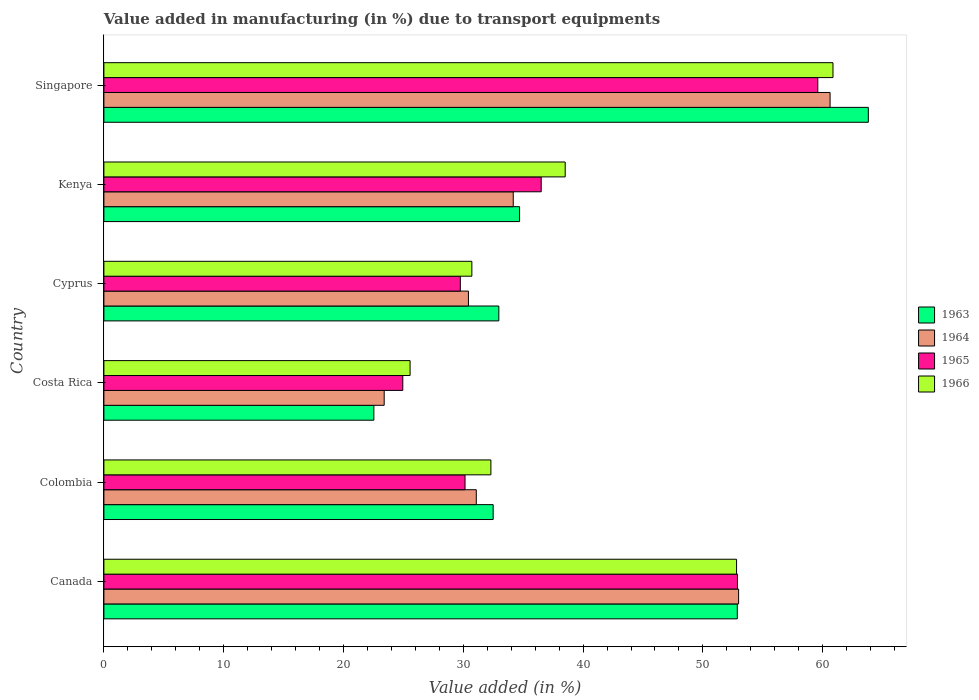How many groups of bars are there?
Your response must be concise. 6. Are the number of bars on each tick of the Y-axis equal?
Your response must be concise. Yes. How many bars are there on the 5th tick from the top?
Keep it short and to the point. 4. In how many cases, is the number of bars for a given country not equal to the number of legend labels?
Provide a succinct answer. 0. What is the percentage of value added in manufacturing due to transport equipments in 1966 in Kenya?
Your answer should be very brief. 38.51. Across all countries, what is the maximum percentage of value added in manufacturing due to transport equipments in 1963?
Provide a succinct answer. 63.81. Across all countries, what is the minimum percentage of value added in manufacturing due to transport equipments in 1965?
Provide a succinct answer. 24.95. In which country was the percentage of value added in manufacturing due to transport equipments in 1964 maximum?
Your answer should be compact. Singapore. What is the total percentage of value added in manufacturing due to transport equipments in 1964 in the graph?
Ensure brevity in your answer.  232.68. What is the difference between the percentage of value added in manufacturing due to transport equipments in 1966 in Costa Rica and that in Kenya?
Make the answer very short. -12.95. What is the difference between the percentage of value added in manufacturing due to transport equipments in 1965 in Cyprus and the percentage of value added in manufacturing due to transport equipments in 1966 in Kenya?
Make the answer very short. -8.75. What is the average percentage of value added in manufacturing due to transport equipments in 1966 per country?
Ensure brevity in your answer.  40.13. What is the difference between the percentage of value added in manufacturing due to transport equipments in 1964 and percentage of value added in manufacturing due to transport equipments in 1966 in Costa Rica?
Provide a succinct answer. -2.16. What is the ratio of the percentage of value added in manufacturing due to transport equipments in 1966 in Costa Rica to that in Kenya?
Ensure brevity in your answer.  0.66. What is the difference between the highest and the second highest percentage of value added in manufacturing due to transport equipments in 1966?
Provide a short and direct response. 8.05. What is the difference between the highest and the lowest percentage of value added in manufacturing due to transport equipments in 1964?
Offer a terse response. 37.22. Is the sum of the percentage of value added in manufacturing due to transport equipments in 1963 in Colombia and Singapore greater than the maximum percentage of value added in manufacturing due to transport equipments in 1965 across all countries?
Offer a terse response. Yes. Is it the case that in every country, the sum of the percentage of value added in manufacturing due to transport equipments in 1964 and percentage of value added in manufacturing due to transport equipments in 1965 is greater than the sum of percentage of value added in manufacturing due to transport equipments in 1966 and percentage of value added in manufacturing due to transport equipments in 1963?
Your answer should be very brief. No. What does the 2nd bar from the top in Kenya represents?
Offer a terse response. 1965. What does the 3rd bar from the bottom in Singapore represents?
Ensure brevity in your answer.  1965. How many countries are there in the graph?
Your answer should be very brief. 6. What is the difference between two consecutive major ticks on the X-axis?
Your answer should be very brief. 10. Are the values on the major ticks of X-axis written in scientific E-notation?
Offer a very short reply. No. Where does the legend appear in the graph?
Provide a succinct answer. Center right. How are the legend labels stacked?
Offer a terse response. Vertical. What is the title of the graph?
Make the answer very short. Value added in manufacturing (in %) due to transport equipments. What is the label or title of the X-axis?
Keep it short and to the point. Value added (in %). What is the Value added (in %) in 1963 in Canada?
Your answer should be compact. 52.87. What is the Value added (in %) of 1964 in Canada?
Give a very brief answer. 52.98. What is the Value added (in %) in 1965 in Canada?
Give a very brief answer. 52.89. What is the Value added (in %) in 1966 in Canada?
Keep it short and to the point. 52.81. What is the Value added (in %) of 1963 in Colombia?
Offer a very short reply. 32.49. What is the Value added (in %) of 1964 in Colombia?
Ensure brevity in your answer.  31.09. What is the Value added (in %) in 1965 in Colombia?
Provide a succinct answer. 30.15. What is the Value added (in %) in 1966 in Colombia?
Your answer should be compact. 32.3. What is the Value added (in %) of 1963 in Costa Rica?
Your response must be concise. 22.53. What is the Value added (in %) in 1964 in Costa Rica?
Provide a short and direct response. 23.4. What is the Value added (in %) of 1965 in Costa Rica?
Your response must be concise. 24.95. What is the Value added (in %) of 1966 in Costa Rica?
Provide a succinct answer. 25.56. What is the Value added (in %) in 1963 in Cyprus?
Your answer should be compact. 32.97. What is the Value added (in %) of 1964 in Cyprus?
Make the answer very short. 30.43. What is the Value added (in %) in 1965 in Cyprus?
Offer a terse response. 29.75. What is the Value added (in %) in 1966 in Cyprus?
Your response must be concise. 30.72. What is the Value added (in %) of 1963 in Kenya?
Keep it short and to the point. 34.7. What is the Value added (in %) of 1964 in Kenya?
Provide a short and direct response. 34.17. What is the Value added (in %) of 1965 in Kenya?
Provide a succinct answer. 36.5. What is the Value added (in %) in 1966 in Kenya?
Make the answer very short. 38.51. What is the Value added (in %) in 1963 in Singapore?
Provide a short and direct response. 63.81. What is the Value added (in %) of 1964 in Singapore?
Offer a terse response. 60.62. What is the Value added (in %) in 1965 in Singapore?
Your answer should be very brief. 59.59. What is the Value added (in %) of 1966 in Singapore?
Offer a terse response. 60.86. Across all countries, what is the maximum Value added (in %) in 1963?
Make the answer very short. 63.81. Across all countries, what is the maximum Value added (in %) of 1964?
Your answer should be very brief. 60.62. Across all countries, what is the maximum Value added (in %) in 1965?
Your response must be concise. 59.59. Across all countries, what is the maximum Value added (in %) in 1966?
Offer a terse response. 60.86. Across all countries, what is the minimum Value added (in %) of 1963?
Your answer should be very brief. 22.53. Across all countries, what is the minimum Value added (in %) in 1964?
Provide a succinct answer. 23.4. Across all countries, what is the minimum Value added (in %) of 1965?
Your response must be concise. 24.95. Across all countries, what is the minimum Value added (in %) of 1966?
Provide a succinct answer. 25.56. What is the total Value added (in %) of 1963 in the graph?
Ensure brevity in your answer.  239.38. What is the total Value added (in %) in 1964 in the graph?
Provide a succinct answer. 232.68. What is the total Value added (in %) in 1965 in the graph?
Make the answer very short. 233.83. What is the total Value added (in %) of 1966 in the graph?
Make the answer very short. 240.76. What is the difference between the Value added (in %) in 1963 in Canada and that in Colombia?
Offer a very short reply. 20.38. What is the difference between the Value added (in %) of 1964 in Canada and that in Colombia?
Give a very brief answer. 21.9. What is the difference between the Value added (in %) in 1965 in Canada and that in Colombia?
Your answer should be compact. 22.74. What is the difference between the Value added (in %) in 1966 in Canada and that in Colombia?
Your answer should be very brief. 20.51. What is the difference between the Value added (in %) in 1963 in Canada and that in Costa Rica?
Give a very brief answer. 30.34. What is the difference between the Value added (in %) in 1964 in Canada and that in Costa Rica?
Provide a succinct answer. 29.59. What is the difference between the Value added (in %) in 1965 in Canada and that in Costa Rica?
Keep it short and to the point. 27.93. What is the difference between the Value added (in %) in 1966 in Canada and that in Costa Rica?
Provide a succinct answer. 27.25. What is the difference between the Value added (in %) of 1963 in Canada and that in Cyprus?
Offer a very short reply. 19.91. What is the difference between the Value added (in %) in 1964 in Canada and that in Cyprus?
Ensure brevity in your answer.  22.55. What is the difference between the Value added (in %) in 1965 in Canada and that in Cyprus?
Make the answer very short. 23.13. What is the difference between the Value added (in %) of 1966 in Canada and that in Cyprus?
Make the answer very short. 22.1. What is the difference between the Value added (in %) in 1963 in Canada and that in Kenya?
Offer a terse response. 18.17. What is the difference between the Value added (in %) in 1964 in Canada and that in Kenya?
Offer a very short reply. 18.81. What is the difference between the Value added (in %) in 1965 in Canada and that in Kenya?
Your response must be concise. 16.38. What is the difference between the Value added (in %) in 1966 in Canada and that in Kenya?
Your answer should be compact. 14.3. What is the difference between the Value added (in %) of 1963 in Canada and that in Singapore?
Offer a very short reply. -10.94. What is the difference between the Value added (in %) of 1964 in Canada and that in Singapore?
Keep it short and to the point. -7.63. What is the difference between the Value added (in %) in 1965 in Canada and that in Singapore?
Your answer should be very brief. -6.71. What is the difference between the Value added (in %) of 1966 in Canada and that in Singapore?
Give a very brief answer. -8.05. What is the difference between the Value added (in %) in 1963 in Colombia and that in Costa Rica?
Provide a succinct answer. 9.96. What is the difference between the Value added (in %) of 1964 in Colombia and that in Costa Rica?
Offer a very short reply. 7.69. What is the difference between the Value added (in %) in 1965 in Colombia and that in Costa Rica?
Give a very brief answer. 5.2. What is the difference between the Value added (in %) of 1966 in Colombia and that in Costa Rica?
Offer a terse response. 6.74. What is the difference between the Value added (in %) of 1963 in Colombia and that in Cyprus?
Keep it short and to the point. -0.47. What is the difference between the Value added (in %) of 1964 in Colombia and that in Cyprus?
Provide a succinct answer. 0.66. What is the difference between the Value added (in %) of 1965 in Colombia and that in Cyprus?
Your answer should be very brief. 0.39. What is the difference between the Value added (in %) in 1966 in Colombia and that in Cyprus?
Make the answer very short. 1.59. What is the difference between the Value added (in %) of 1963 in Colombia and that in Kenya?
Your answer should be very brief. -2.21. What is the difference between the Value added (in %) in 1964 in Colombia and that in Kenya?
Your answer should be very brief. -3.08. What is the difference between the Value added (in %) of 1965 in Colombia and that in Kenya?
Your answer should be very brief. -6.36. What is the difference between the Value added (in %) of 1966 in Colombia and that in Kenya?
Make the answer very short. -6.2. What is the difference between the Value added (in %) of 1963 in Colombia and that in Singapore?
Provide a short and direct response. -31.32. What is the difference between the Value added (in %) in 1964 in Colombia and that in Singapore?
Provide a succinct answer. -29.53. What is the difference between the Value added (in %) in 1965 in Colombia and that in Singapore?
Provide a short and direct response. -29.45. What is the difference between the Value added (in %) of 1966 in Colombia and that in Singapore?
Your answer should be very brief. -28.56. What is the difference between the Value added (in %) in 1963 in Costa Rica and that in Cyprus?
Ensure brevity in your answer.  -10.43. What is the difference between the Value added (in %) in 1964 in Costa Rica and that in Cyprus?
Provide a succinct answer. -7.03. What is the difference between the Value added (in %) of 1965 in Costa Rica and that in Cyprus?
Your answer should be very brief. -4.8. What is the difference between the Value added (in %) of 1966 in Costa Rica and that in Cyprus?
Make the answer very short. -5.16. What is the difference between the Value added (in %) in 1963 in Costa Rica and that in Kenya?
Ensure brevity in your answer.  -12.17. What is the difference between the Value added (in %) in 1964 in Costa Rica and that in Kenya?
Provide a succinct answer. -10.77. What is the difference between the Value added (in %) in 1965 in Costa Rica and that in Kenya?
Your answer should be compact. -11.55. What is the difference between the Value added (in %) of 1966 in Costa Rica and that in Kenya?
Your answer should be compact. -12.95. What is the difference between the Value added (in %) of 1963 in Costa Rica and that in Singapore?
Provide a short and direct response. -41.28. What is the difference between the Value added (in %) in 1964 in Costa Rica and that in Singapore?
Ensure brevity in your answer.  -37.22. What is the difference between the Value added (in %) of 1965 in Costa Rica and that in Singapore?
Your response must be concise. -34.64. What is the difference between the Value added (in %) in 1966 in Costa Rica and that in Singapore?
Your answer should be compact. -35.3. What is the difference between the Value added (in %) in 1963 in Cyprus and that in Kenya?
Give a very brief answer. -1.73. What is the difference between the Value added (in %) in 1964 in Cyprus and that in Kenya?
Your response must be concise. -3.74. What is the difference between the Value added (in %) in 1965 in Cyprus and that in Kenya?
Your answer should be compact. -6.75. What is the difference between the Value added (in %) in 1966 in Cyprus and that in Kenya?
Provide a short and direct response. -7.79. What is the difference between the Value added (in %) in 1963 in Cyprus and that in Singapore?
Provide a succinct answer. -30.84. What is the difference between the Value added (in %) of 1964 in Cyprus and that in Singapore?
Ensure brevity in your answer.  -30.19. What is the difference between the Value added (in %) of 1965 in Cyprus and that in Singapore?
Ensure brevity in your answer.  -29.84. What is the difference between the Value added (in %) of 1966 in Cyprus and that in Singapore?
Your response must be concise. -30.14. What is the difference between the Value added (in %) in 1963 in Kenya and that in Singapore?
Your response must be concise. -29.11. What is the difference between the Value added (in %) in 1964 in Kenya and that in Singapore?
Offer a terse response. -26.45. What is the difference between the Value added (in %) of 1965 in Kenya and that in Singapore?
Give a very brief answer. -23.09. What is the difference between the Value added (in %) in 1966 in Kenya and that in Singapore?
Your response must be concise. -22.35. What is the difference between the Value added (in %) in 1963 in Canada and the Value added (in %) in 1964 in Colombia?
Your answer should be compact. 21.79. What is the difference between the Value added (in %) in 1963 in Canada and the Value added (in %) in 1965 in Colombia?
Provide a short and direct response. 22.73. What is the difference between the Value added (in %) in 1963 in Canada and the Value added (in %) in 1966 in Colombia?
Provide a succinct answer. 20.57. What is the difference between the Value added (in %) of 1964 in Canada and the Value added (in %) of 1965 in Colombia?
Ensure brevity in your answer.  22.84. What is the difference between the Value added (in %) in 1964 in Canada and the Value added (in %) in 1966 in Colombia?
Offer a terse response. 20.68. What is the difference between the Value added (in %) of 1965 in Canada and the Value added (in %) of 1966 in Colombia?
Your response must be concise. 20.58. What is the difference between the Value added (in %) of 1963 in Canada and the Value added (in %) of 1964 in Costa Rica?
Offer a very short reply. 29.48. What is the difference between the Value added (in %) of 1963 in Canada and the Value added (in %) of 1965 in Costa Rica?
Provide a short and direct response. 27.92. What is the difference between the Value added (in %) in 1963 in Canada and the Value added (in %) in 1966 in Costa Rica?
Give a very brief answer. 27.31. What is the difference between the Value added (in %) of 1964 in Canada and the Value added (in %) of 1965 in Costa Rica?
Provide a succinct answer. 28.03. What is the difference between the Value added (in %) of 1964 in Canada and the Value added (in %) of 1966 in Costa Rica?
Your answer should be very brief. 27.42. What is the difference between the Value added (in %) of 1965 in Canada and the Value added (in %) of 1966 in Costa Rica?
Your answer should be very brief. 27.33. What is the difference between the Value added (in %) of 1963 in Canada and the Value added (in %) of 1964 in Cyprus?
Offer a terse response. 22.44. What is the difference between the Value added (in %) in 1963 in Canada and the Value added (in %) in 1965 in Cyprus?
Ensure brevity in your answer.  23.12. What is the difference between the Value added (in %) of 1963 in Canada and the Value added (in %) of 1966 in Cyprus?
Your answer should be compact. 22.16. What is the difference between the Value added (in %) in 1964 in Canada and the Value added (in %) in 1965 in Cyprus?
Your answer should be very brief. 23.23. What is the difference between the Value added (in %) in 1964 in Canada and the Value added (in %) in 1966 in Cyprus?
Provide a succinct answer. 22.27. What is the difference between the Value added (in %) in 1965 in Canada and the Value added (in %) in 1966 in Cyprus?
Make the answer very short. 22.17. What is the difference between the Value added (in %) of 1963 in Canada and the Value added (in %) of 1964 in Kenya?
Your answer should be compact. 18.7. What is the difference between the Value added (in %) in 1963 in Canada and the Value added (in %) in 1965 in Kenya?
Your answer should be compact. 16.37. What is the difference between the Value added (in %) of 1963 in Canada and the Value added (in %) of 1966 in Kenya?
Offer a terse response. 14.37. What is the difference between the Value added (in %) in 1964 in Canada and the Value added (in %) in 1965 in Kenya?
Provide a succinct answer. 16.48. What is the difference between the Value added (in %) in 1964 in Canada and the Value added (in %) in 1966 in Kenya?
Offer a very short reply. 14.47. What is the difference between the Value added (in %) in 1965 in Canada and the Value added (in %) in 1966 in Kenya?
Provide a succinct answer. 14.38. What is the difference between the Value added (in %) in 1963 in Canada and the Value added (in %) in 1964 in Singapore?
Your answer should be compact. -7.74. What is the difference between the Value added (in %) in 1963 in Canada and the Value added (in %) in 1965 in Singapore?
Offer a very short reply. -6.72. What is the difference between the Value added (in %) in 1963 in Canada and the Value added (in %) in 1966 in Singapore?
Your answer should be very brief. -7.99. What is the difference between the Value added (in %) of 1964 in Canada and the Value added (in %) of 1965 in Singapore?
Keep it short and to the point. -6.61. What is the difference between the Value added (in %) in 1964 in Canada and the Value added (in %) in 1966 in Singapore?
Give a very brief answer. -7.88. What is the difference between the Value added (in %) of 1965 in Canada and the Value added (in %) of 1966 in Singapore?
Offer a very short reply. -7.97. What is the difference between the Value added (in %) of 1963 in Colombia and the Value added (in %) of 1964 in Costa Rica?
Make the answer very short. 9.1. What is the difference between the Value added (in %) in 1963 in Colombia and the Value added (in %) in 1965 in Costa Rica?
Provide a short and direct response. 7.54. What is the difference between the Value added (in %) of 1963 in Colombia and the Value added (in %) of 1966 in Costa Rica?
Your answer should be very brief. 6.93. What is the difference between the Value added (in %) in 1964 in Colombia and the Value added (in %) in 1965 in Costa Rica?
Your answer should be compact. 6.14. What is the difference between the Value added (in %) in 1964 in Colombia and the Value added (in %) in 1966 in Costa Rica?
Offer a very short reply. 5.53. What is the difference between the Value added (in %) of 1965 in Colombia and the Value added (in %) of 1966 in Costa Rica?
Your response must be concise. 4.59. What is the difference between the Value added (in %) in 1963 in Colombia and the Value added (in %) in 1964 in Cyprus?
Ensure brevity in your answer.  2.06. What is the difference between the Value added (in %) in 1963 in Colombia and the Value added (in %) in 1965 in Cyprus?
Keep it short and to the point. 2.74. What is the difference between the Value added (in %) in 1963 in Colombia and the Value added (in %) in 1966 in Cyprus?
Make the answer very short. 1.78. What is the difference between the Value added (in %) in 1964 in Colombia and the Value added (in %) in 1965 in Cyprus?
Your answer should be very brief. 1.33. What is the difference between the Value added (in %) of 1964 in Colombia and the Value added (in %) of 1966 in Cyprus?
Your response must be concise. 0.37. What is the difference between the Value added (in %) of 1965 in Colombia and the Value added (in %) of 1966 in Cyprus?
Provide a short and direct response. -0.57. What is the difference between the Value added (in %) in 1963 in Colombia and the Value added (in %) in 1964 in Kenya?
Your answer should be very brief. -1.68. What is the difference between the Value added (in %) of 1963 in Colombia and the Value added (in %) of 1965 in Kenya?
Give a very brief answer. -4.01. What is the difference between the Value added (in %) in 1963 in Colombia and the Value added (in %) in 1966 in Kenya?
Your answer should be very brief. -6.01. What is the difference between the Value added (in %) of 1964 in Colombia and the Value added (in %) of 1965 in Kenya?
Give a very brief answer. -5.42. What is the difference between the Value added (in %) in 1964 in Colombia and the Value added (in %) in 1966 in Kenya?
Provide a short and direct response. -7.42. What is the difference between the Value added (in %) of 1965 in Colombia and the Value added (in %) of 1966 in Kenya?
Your answer should be very brief. -8.36. What is the difference between the Value added (in %) of 1963 in Colombia and the Value added (in %) of 1964 in Singapore?
Provide a short and direct response. -28.12. What is the difference between the Value added (in %) in 1963 in Colombia and the Value added (in %) in 1965 in Singapore?
Keep it short and to the point. -27.1. What is the difference between the Value added (in %) in 1963 in Colombia and the Value added (in %) in 1966 in Singapore?
Ensure brevity in your answer.  -28.37. What is the difference between the Value added (in %) in 1964 in Colombia and the Value added (in %) in 1965 in Singapore?
Make the answer very short. -28.51. What is the difference between the Value added (in %) in 1964 in Colombia and the Value added (in %) in 1966 in Singapore?
Provide a succinct answer. -29.77. What is the difference between the Value added (in %) in 1965 in Colombia and the Value added (in %) in 1966 in Singapore?
Your response must be concise. -30.71. What is the difference between the Value added (in %) of 1963 in Costa Rica and the Value added (in %) of 1964 in Cyprus?
Provide a succinct answer. -7.9. What is the difference between the Value added (in %) of 1963 in Costa Rica and the Value added (in %) of 1965 in Cyprus?
Your answer should be very brief. -7.22. What is the difference between the Value added (in %) of 1963 in Costa Rica and the Value added (in %) of 1966 in Cyprus?
Provide a succinct answer. -8.18. What is the difference between the Value added (in %) in 1964 in Costa Rica and the Value added (in %) in 1965 in Cyprus?
Keep it short and to the point. -6.36. What is the difference between the Value added (in %) in 1964 in Costa Rica and the Value added (in %) in 1966 in Cyprus?
Your response must be concise. -7.32. What is the difference between the Value added (in %) in 1965 in Costa Rica and the Value added (in %) in 1966 in Cyprus?
Make the answer very short. -5.77. What is the difference between the Value added (in %) of 1963 in Costa Rica and the Value added (in %) of 1964 in Kenya?
Keep it short and to the point. -11.64. What is the difference between the Value added (in %) in 1963 in Costa Rica and the Value added (in %) in 1965 in Kenya?
Give a very brief answer. -13.97. What is the difference between the Value added (in %) of 1963 in Costa Rica and the Value added (in %) of 1966 in Kenya?
Provide a short and direct response. -15.97. What is the difference between the Value added (in %) in 1964 in Costa Rica and the Value added (in %) in 1965 in Kenya?
Your response must be concise. -13.11. What is the difference between the Value added (in %) of 1964 in Costa Rica and the Value added (in %) of 1966 in Kenya?
Make the answer very short. -15.11. What is the difference between the Value added (in %) of 1965 in Costa Rica and the Value added (in %) of 1966 in Kenya?
Provide a succinct answer. -13.56. What is the difference between the Value added (in %) in 1963 in Costa Rica and the Value added (in %) in 1964 in Singapore?
Provide a succinct answer. -38.08. What is the difference between the Value added (in %) of 1963 in Costa Rica and the Value added (in %) of 1965 in Singapore?
Your answer should be very brief. -37.06. What is the difference between the Value added (in %) in 1963 in Costa Rica and the Value added (in %) in 1966 in Singapore?
Provide a succinct answer. -38.33. What is the difference between the Value added (in %) of 1964 in Costa Rica and the Value added (in %) of 1965 in Singapore?
Provide a short and direct response. -36.19. What is the difference between the Value added (in %) of 1964 in Costa Rica and the Value added (in %) of 1966 in Singapore?
Your answer should be very brief. -37.46. What is the difference between the Value added (in %) of 1965 in Costa Rica and the Value added (in %) of 1966 in Singapore?
Offer a terse response. -35.91. What is the difference between the Value added (in %) of 1963 in Cyprus and the Value added (in %) of 1964 in Kenya?
Keep it short and to the point. -1.2. What is the difference between the Value added (in %) in 1963 in Cyprus and the Value added (in %) in 1965 in Kenya?
Provide a succinct answer. -3.54. What is the difference between the Value added (in %) in 1963 in Cyprus and the Value added (in %) in 1966 in Kenya?
Keep it short and to the point. -5.54. What is the difference between the Value added (in %) of 1964 in Cyprus and the Value added (in %) of 1965 in Kenya?
Your answer should be compact. -6.07. What is the difference between the Value added (in %) of 1964 in Cyprus and the Value added (in %) of 1966 in Kenya?
Ensure brevity in your answer.  -8.08. What is the difference between the Value added (in %) in 1965 in Cyprus and the Value added (in %) in 1966 in Kenya?
Offer a terse response. -8.75. What is the difference between the Value added (in %) in 1963 in Cyprus and the Value added (in %) in 1964 in Singapore?
Your answer should be compact. -27.65. What is the difference between the Value added (in %) of 1963 in Cyprus and the Value added (in %) of 1965 in Singapore?
Ensure brevity in your answer.  -26.62. What is the difference between the Value added (in %) in 1963 in Cyprus and the Value added (in %) in 1966 in Singapore?
Give a very brief answer. -27.89. What is the difference between the Value added (in %) in 1964 in Cyprus and the Value added (in %) in 1965 in Singapore?
Your answer should be very brief. -29.16. What is the difference between the Value added (in %) of 1964 in Cyprus and the Value added (in %) of 1966 in Singapore?
Provide a succinct answer. -30.43. What is the difference between the Value added (in %) of 1965 in Cyprus and the Value added (in %) of 1966 in Singapore?
Your answer should be very brief. -31.11. What is the difference between the Value added (in %) in 1963 in Kenya and the Value added (in %) in 1964 in Singapore?
Your answer should be very brief. -25.92. What is the difference between the Value added (in %) of 1963 in Kenya and the Value added (in %) of 1965 in Singapore?
Your response must be concise. -24.89. What is the difference between the Value added (in %) in 1963 in Kenya and the Value added (in %) in 1966 in Singapore?
Offer a terse response. -26.16. What is the difference between the Value added (in %) of 1964 in Kenya and the Value added (in %) of 1965 in Singapore?
Provide a succinct answer. -25.42. What is the difference between the Value added (in %) in 1964 in Kenya and the Value added (in %) in 1966 in Singapore?
Ensure brevity in your answer.  -26.69. What is the difference between the Value added (in %) in 1965 in Kenya and the Value added (in %) in 1966 in Singapore?
Make the answer very short. -24.36. What is the average Value added (in %) of 1963 per country?
Give a very brief answer. 39.9. What is the average Value added (in %) of 1964 per country?
Your response must be concise. 38.78. What is the average Value added (in %) of 1965 per country?
Your answer should be very brief. 38.97. What is the average Value added (in %) of 1966 per country?
Ensure brevity in your answer.  40.13. What is the difference between the Value added (in %) in 1963 and Value added (in %) in 1964 in Canada?
Provide a short and direct response. -0.11. What is the difference between the Value added (in %) in 1963 and Value added (in %) in 1965 in Canada?
Make the answer very short. -0.01. What is the difference between the Value added (in %) in 1963 and Value added (in %) in 1966 in Canada?
Keep it short and to the point. 0.06. What is the difference between the Value added (in %) in 1964 and Value added (in %) in 1965 in Canada?
Your answer should be very brief. 0.1. What is the difference between the Value added (in %) of 1964 and Value added (in %) of 1966 in Canada?
Your answer should be very brief. 0.17. What is the difference between the Value added (in %) in 1965 and Value added (in %) in 1966 in Canada?
Give a very brief answer. 0.07. What is the difference between the Value added (in %) of 1963 and Value added (in %) of 1964 in Colombia?
Provide a short and direct response. 1.41. What is the difference between the Value added (in %) of 1963 and Value added (in %) of 1965 in Colombia?
Ensure brevity in your answer.  2.35. What is the difference between the Value added (in %) of 1963 and Value added (in %) of 1966 in Colombia?
Your answer should be compact. 0.19. What is the difference between the Value added (in %) of 1964 and Value added (in %) of 1965 in Colombia?
Keep it short and to the point. 0.94. What is the difference between the Value added (in %) in 1964 and Value added (in %) in 1966 in Colombia?
Your answer should be very brief. -1.22. What is the difference between the Value added (in %) of 1965 and Value added (in %) of 1966 in Colombia?
Your answer should be very brief. -2.16. What is the difference between the Value added (in %) in 1963 and Value added (in %) in 1964 in Costa Rica?
Keep it short and to the point. -0.86. What is the difference between the Value added (in %) of 1963 and Value added (in %) of 1965 in Costa Rica?
Provide a succinct answer. -2.42. What is the difference between the Value added (in %) of 1963 and Value added (in %) of 1966 in Costa Rica?
Your response must be concise. -3.03. What is the difference between the Value added (in %) of 1964 and Value added (in %) of 1965 in Costa Rica?
Keep it short and to the point. -1.55. What is the difference between the Value added (in %) in 1964 and Value added (in %) in 1966 in Costa Rica?
Provide a succinct answer. -2.16. What is the difference between the Value added (in %) in 1965 and Value added (in %) in 1966 in Costa Rica?
Make the answer very short. -0.61. What is the difference between the Value added (in %) of 1963 and Value added (in %) of 1964 in Cyprus?
Your answer should be compact. 2.54. What is the difference between the Value added (in %) in 1963 and Value added (in %) in 1965 in Cyprus?
Your response must be concise. 3.21. What is the difference between the Value added (in %) of 1963 and Value added (in %) of 1966 in Cyprus?
Keep it short and to the point. 2.25. What is the difference between the Value added (in %) in 1964 and Value added (in %) in 1965 in Cyprus?
Provide a succinct answer. 0.68. What is the difference between the Value added (in %) of 1964 and Value added (in %) of 1966 in Cyprus?
Ensure brevity in your answer.  -0.29. What is the difference between the Value added (in %) in 1965 and Value added (in %) in 1966 in Cyprus?
Keep it short and to the point. -0.96. What is the difference between the Value added (in %) in 1963 and Value added (in %) in 1964 in Kenya?
Provide a short and direct response. 0.53. What is the difference between the Value added (in %) of 1963 and Value added (in %) of 1965 in Kenya?
Your answer should be very brief. -1.8. What is the difference between the Value added (in %) in 1963 and Value added (in %) in 1966 in Kenya?
Your answer should be compact. -3.81. What is the difference between the Value added (in %) in 1964 and Value added (in %) in 1965 in Kenya?
Your answer should be very brief. -2.33. What is the difference between the Value added (in %) of 1964 and Value added (in %) of 1966 in Kenya?
Provide a succinct answer. -4.34. What is the difference between the Value added (in %) of 1965 and Value added (in %) of 1966 in Kenya?
Provide a succinct answer. -2. What is the difference between the Value added (in %) in 1963 and Value added (in %) in 1964 in Singapore?
Offer a terse response. 3.19. What is the difference between the Value added (in %) in 1963 and Value added (in %) in 1965 in Singapore?
Make the answer very short. 4.22. What is the difference between the Value added (in %) of 1963 and Value added (in %) of 1966 in Singapore?
Your answer should be very brief. 2.95. What is the difference between the Value added (in %) of 1964 and Value added (in %) of 1965 in Singapore?
Offer a terse response. 1.03. What is the difference between the Value added (in %) in 1964 and Value added (in %) in 1966 in Singapore?
Provide a succinct answer. -0.24. What is the difference between the Value added (in %) of 1965 and Value added (in %) of 1966 in Singapore?
Give a very brief answer. -1.27. What is the ratio of the Value added (in %) of 1963 in Canada to that in Colombia?
Make the answer very short. 1.63. What is the ratio of the Value added (in %) of 1964 in Canada to that in Colombia?
Give a very brief answer. 1.7. What is the ratio of the Value added (in %) of 1965 in Canada to that in Colombia?
Your answer should be compact. 1.75. What is the ratio of the Value added (in %) of 1966 in Canada to that in Colombia?
Keep it short and to the point. 1.63. What is the ratio of the Value added (in %) in 1963 in Canada to that in Costa Rica?
Your answer should be compact. 2.35. What is the ratio of the Value added (in %) of 1964 in Canada to that in Costa Rica?
Your answer should be compact. 2.26. What is the ratio of the Value added (in %) of 1965 in Canada to that in Costa Rica?
Offer a very short reply. 2.12. What is the ratio of the Value added (in %) of 1966 in Canada to that in Costa Rica?
Ensure brevity in your answer.  2.07. What is the ratio of the Value added (in %) in 1963 in Canada to that in Cyprus?
Offer a very short reply. 1.6. What is the ratio of the Value added (in %) of 1964 in Canada to that in Cyprus?
Offer a very short reply. 1.74. What is the ratio of the Value added (in %) in 1965 in Canada to that in Cyprus?
Your answer should be compact. 1.78. What is the ratio of the Value added (in %) of 1966 in Canada to that in Cyprus?
Your answer should be compact. 1.72. What is the ratio of the Value added (in %) in 1963 in Canada to that in Kenya?
Offer a terse response. 1.52. What is the ratio of the Value added (in %) in 1964 in Canada to that in Kenya?
Make the answer very short. 1.55. What is the ratio of the Value added (in %) of 1965 in Canada to that in Kenya?
Offer a very short reply. 1.45. What is the ratio of the Value added (in %) of 1966 in Canada to that in Kenya?
Give a very brief answer. 1.37. What is the ratio of the Value added (in %) in 1963 in Canada to that in Singapore?
Ensure brevity in your answer.  0.83. What is the ratio of the Value added (in %) of 1964 in Canada to that in Singapore?
Offer a very short reply. 0.87. What is the ratio of the Value added (in %) of 1965 in Canada to that in Singapore?
Your response must be concise. 0.89. What is the ratio of the Value added (in %) in 1966 in Canada to that in Singapore?
Your response must be concise. 0.87. What is the ratio of the Value added (in %) of 1963 in Colombia to that in Costa Rica?
Offer a terse response. 1.44. What is the ratio of the Value added (in %) of 1964 in Colombia to that in Costa Rica?
Your answer should be compact. 1.33. What is the ratio of the Value added (in %) in 1965 in Colombia to that in Costa Rica?
Offer a terse response. 1.21. What is the ratio of the Value added (in %) in 1966 in Colombia to that in Costa Rica?
Offer a terse response. 1.26. What is the ratio of the Value added (in %) of 1963 in Colombia to that in Cyprus?
Provide a short and direct response. 0.99. What is the ratio of the Value added (in %) of 1964 in Colombia to that in Cyprus?
Offer a very short reply. 1.02. What is the ratio of the Value added (in %) in 1965 in Colombia to that in Cyprus?
Ensure brevity in your answer.  1.01. What is the ratio of the Value added (in %) in 1966 in Colombia to that in Cyprus?
Provide a succinct answer. 1.05. What is the ratio of the Value added (in %) in 1963 in Colombia to that in Kenya?
Make the answer very short. 0.94. What is the ratio of the Value added (in %) in 1964 in Colombia to that in Kenya?
Offer a terse response. 0.91. What is the ratio of the Value added (in %) in 1965 in Colombia to that in Kenya?
Offer a very short reply. 0.83. What is the ratio of the Value added (in %) of 1966 in Colombia to that in Kenya?
Make the answer very short. 0.84. What is the ratio of the Value added (in %) in 1963 in Colombia to that in Singapore?
Your answer should be very brief. 0.51. What is the ratio of the Value added (in %) of 1964 in Colombia to that in Singapore?
Offer a very short reply. 0.51. What is the ratio of the Value added (in %) of 1965 in Colombia to that in Singapore?
Provide a succinct answer. 0.51. What is the ratio of the Value added (in %) of 1966 in Colombia to that in Singapore?
Your answer should be very brief. 0.53. What is the ratio of the Value added (in %) of 1963 in Costa Rica to that in Cyprus?
Provide a short and direct response. 0.68. What is the ratio of the Value added (in %) of 1964 in Costa Rica to that in Cyprus?
Offer a terse response. 0.77. What is the ratio of the Value added (in %) in 1965 in Costa Rica to that in Cyprus?
Keep it short and to the point. 0.84. What is the ratio of the Value added (in %) of 1966 in Costa Rica to that in Cyprus?
Keep it short and to the point. 0.83. What is the ratio of the Value added (in %) in 1963 in Costa Rica to that in Kenya?
Make the answer very short. 0.65. What is the ratio of the Value added (in %) of 1964 in Costa Rica to that in Kenya?
Make the answer very short. 0.68. What is the ratio of the Value added (in %) of 1965 in Costa Rica to that in Kenya?
Offer a terse response. 0.68. What is the ratio of the Value added (in %) in 1966 in Costa Rica to that in Kenya?
Ensure brevity in your answer.  0.66. What is the ratio of the Value added (in %) of 1963 in Costa Rica to that in Singapore?
Give a very brief answer. 0.35. What is the ratio of the Value added (in %) in 1964 in Costa Rica to that in Singapore?
Your answer should be very brief. 0.39. What is the ratio of the Value added (in %) of 1965 in Costa Rica to that in Singapore?
Keep it short and to the point. 0.42. What is the ratio of the Value added (in %) of 1966 in Costa Rica to that in Singapore?
Give a very brief answer. 0.42. What is the ratio of the Value added (in %) in 1963 in Cyprus to that in Kenya?
Make the answer very short. 0.95. What is the ratio of the Value added (in %) of 1964 in Cyprus to that in Kenya?
Ensure brevity in your answer.  0.89. What is the ratio of the Value added (in %) in 1965 in Cyprus to that in Kenya?
Offer a very short reply. 0.82. What is the ratio of the Value added (in %) of 1966 in Cyprus to that in Kenya?
Your response must be concise. 0.8. What is the ratio of the Value added (in %) of 1963 in Cyprus to that in Singapore?
Your answer should be very brief. 0.52. What is the ratio of the Value added (in %) of 1964 in Cyprus to that in Singapore?
Offer a terse response. 0.5. What is the ratio of the Value added (in %) in 1965 in Cyprus to that in Singapore?
Your answer should be compact. 0.5. What is the ratio of the Value added (in %) of 1966 in Cyprus to that in Singapore?
Keep it short and to the point. 0.5. What is the ratio of the Value added (in %) in 1963 in Kenya to that in Singapore?
Your response must be concise. 0.54. What is the ratio of the Value added (in %) of 1964 in Kenya to that in Singapore?
Your answer should be compact. 0.56. What is the ratio of the Value added (in %) in 1965 in Kenya to that in Singapore?
Make the answer very short. 0.61. What is the ratio of the Value added (in %) in 1966 in Kenya to that in Singapore?
Keep it short and to the point. 0.63. What is the difference between the highest and the second highest Value added (in %) in 1963?
Provide a short and direct response. 10.94. What is the difference between the highest and the second highest Value added (in %) of 1964?
Offer a terse response. 7.63. What is the difference between the highest and the second highest Value added (in %) of 1965?
Your response must be concise. 6.71. What is the difference between the highest and the second highest Value added (in %) in 1966?
Your answer should be compact. 8.05. What is the difference between the highest and the lowest Value added (in %) in 1963?
Offer a very short reply. 41.28. What is the difference between the highest and the lowest Value added (in %) in 1964?
Your answer should be very brief. 37.22. What is the difference between the highest and the lowest Value added (in %) in 1965?
Make the answer very short. 34.64. What is the difference between the highest and the lowest Value added (in %) of 1966?
Offer a very short reply. 35.3. 